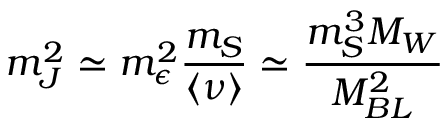Convert formula to latex. <formula><loc_0><loc_0><loc_500><loc_500>m _ { J } ^ { 2 } \simeq m _ { \epsilon } ^ { 2 } { \frac { m _ { S } } { \langle \nu \rangle } } \simeq { \frac { m _ { S } ^ { 3 } M _ { W } } { M _ { B L } ^ { 2 } } }</formula> 